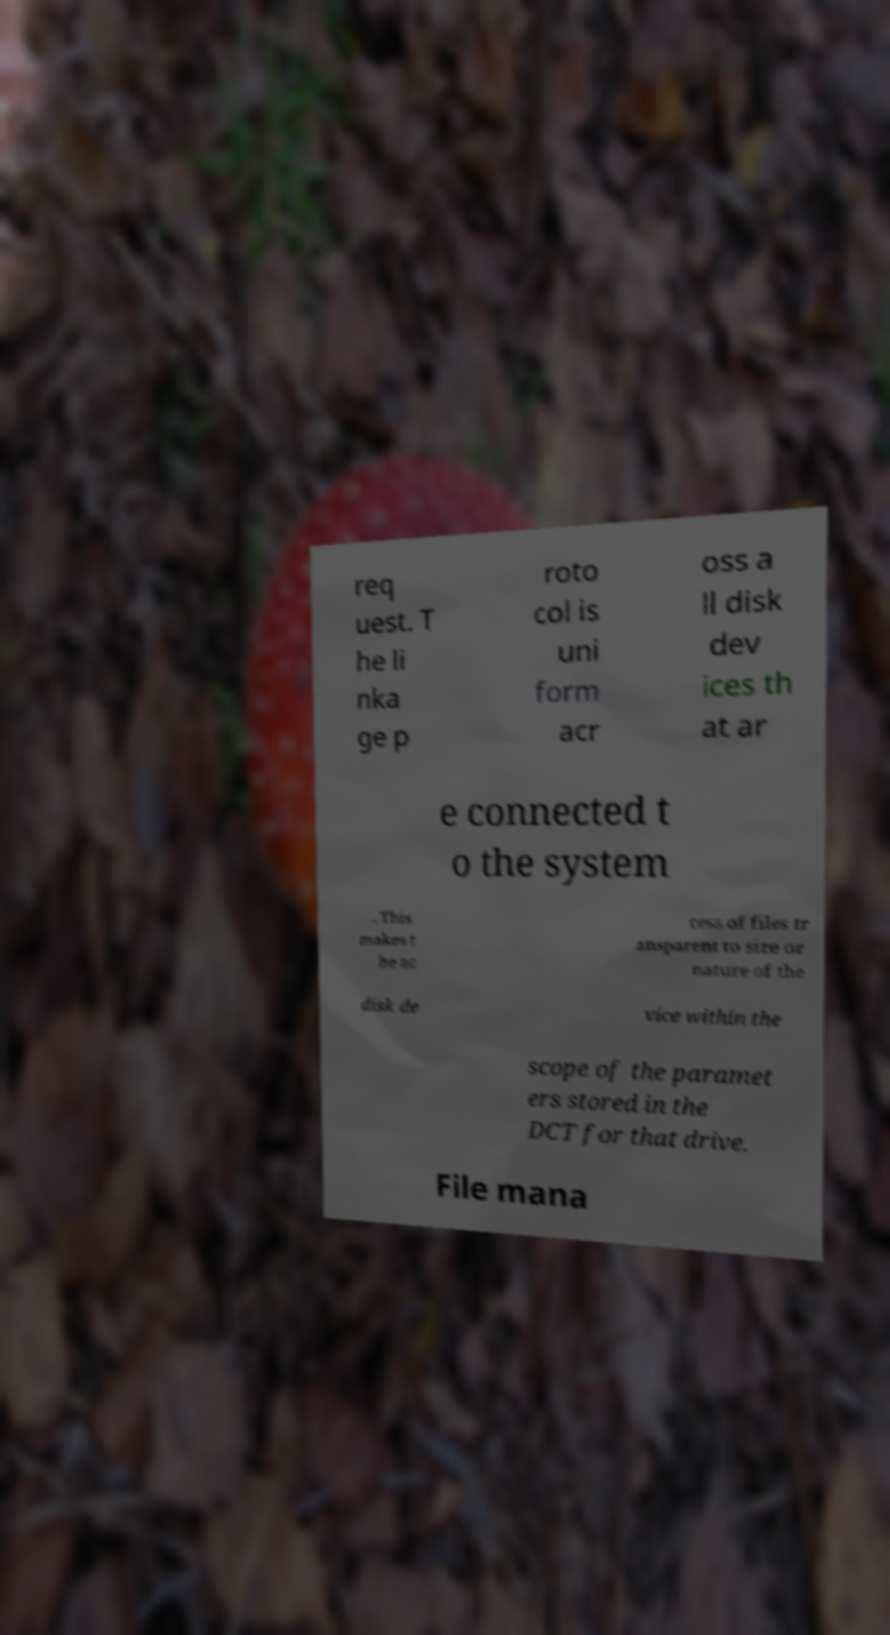Could you extract and type out the text from this image? req uest. T he li nka ge p roto col is uni form acr oss a ll disk dev ices th at ar e connected t o the system . This makes t he ac cess of files tr ansparent to size or nature of the disk de vice within the scope of the paramet ers stored in the DCT for that drive. File mana 